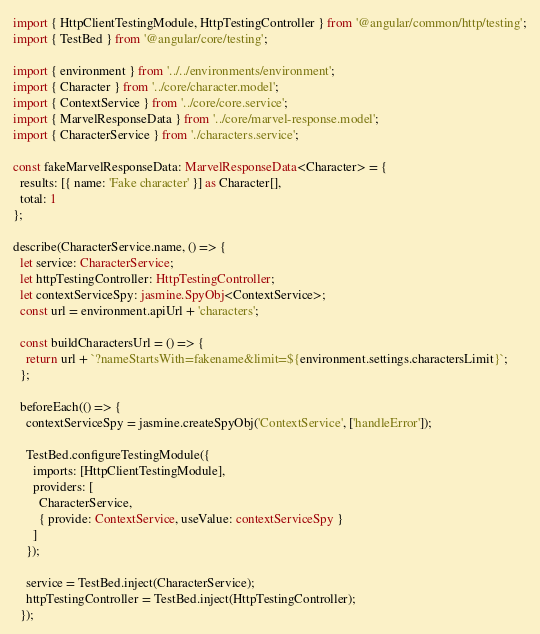Convert code to text. <code><loc_0><loc_0><loc_500><loc_500><_TypeScript_>import { HttpClientTestingModule, HttpTestingController } from '@angular/common/http/testing';
import { TestBed } from '@angular/core/testing';

import { environment } from '../../environments/environment';
import { Character } from '../core/character.model';
import { ContextService } from '../core/core.service';
import { MarvelResponseData } from '../core/marvel-response.model';
import { CharacterService } from './characters.service';

const fakeMarvelResponseData: MarvelResponseData<Character> = {
  results: [{ name: 'Fake character' }] as Character[],
  total: 1
};

describe(CharacterService.name, () => {
  let service: CharacterService;
  let httpTestingController: HttpTestingController;
  let contextServiceSpy: jasmine.SpyObj<ContextService>;
  const url = environment.apiUrl + 'characters';

  const buildCharactersUrl = () => {
    return url + `?nameStartsWith=fakename&limit=${environment.settings.charactersLimit}`;
  };

  beforeEach(() => {
    contextServiceSpy = jasmine.createSpyObj('ContextService', ['handleError']);

    TestBed.configureTestingModule({
      imports: [HttpClientTestingModule],
      providers: [
        CharacterService,
        { provide: ContextService, useValue: contextServiceSpy }
      ]
    });

    service = TestBed.inject(CharacterService);
    httpTestingController = TestBed.inject(HttpTestingController);
  });
</code> 